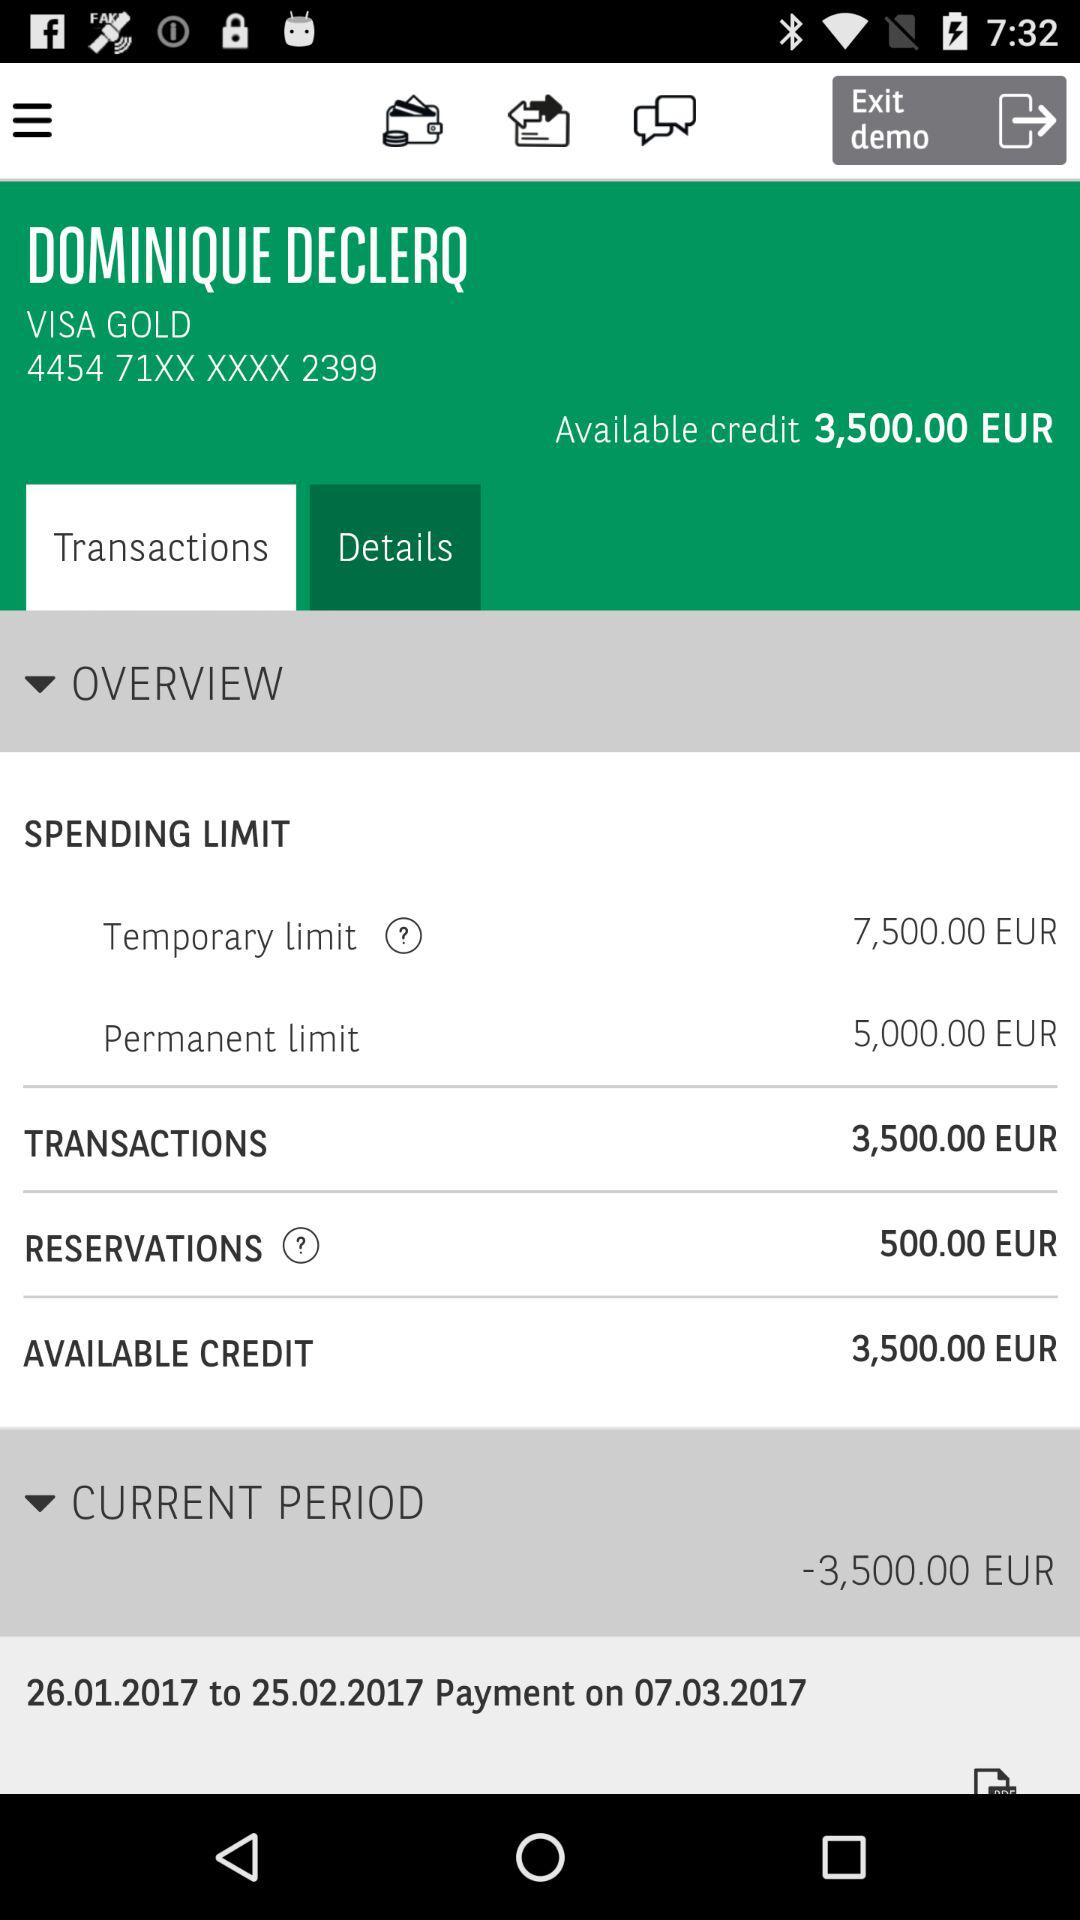What is the permanent spending limit? The permanent spending limit is 5,000 euros. 